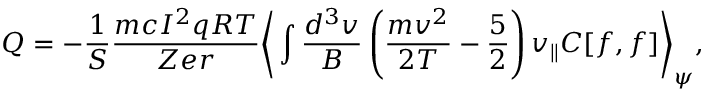<formula> <loc_0><loc_0><loc_500><loc_500>Q = - \frac { 1 } { S } \frac { m c I ^ { 2 } q R T } { Z e r } \left \langle \int \frac { d ^ { 3 } v } { B } \left ( \frac { m v ^ { 2 } } { 2 T } - \frac { 5 } { 2 } \right ) v _ { \| } C [ f , f ] \right \rangle _ { \psi } ,</formula> 